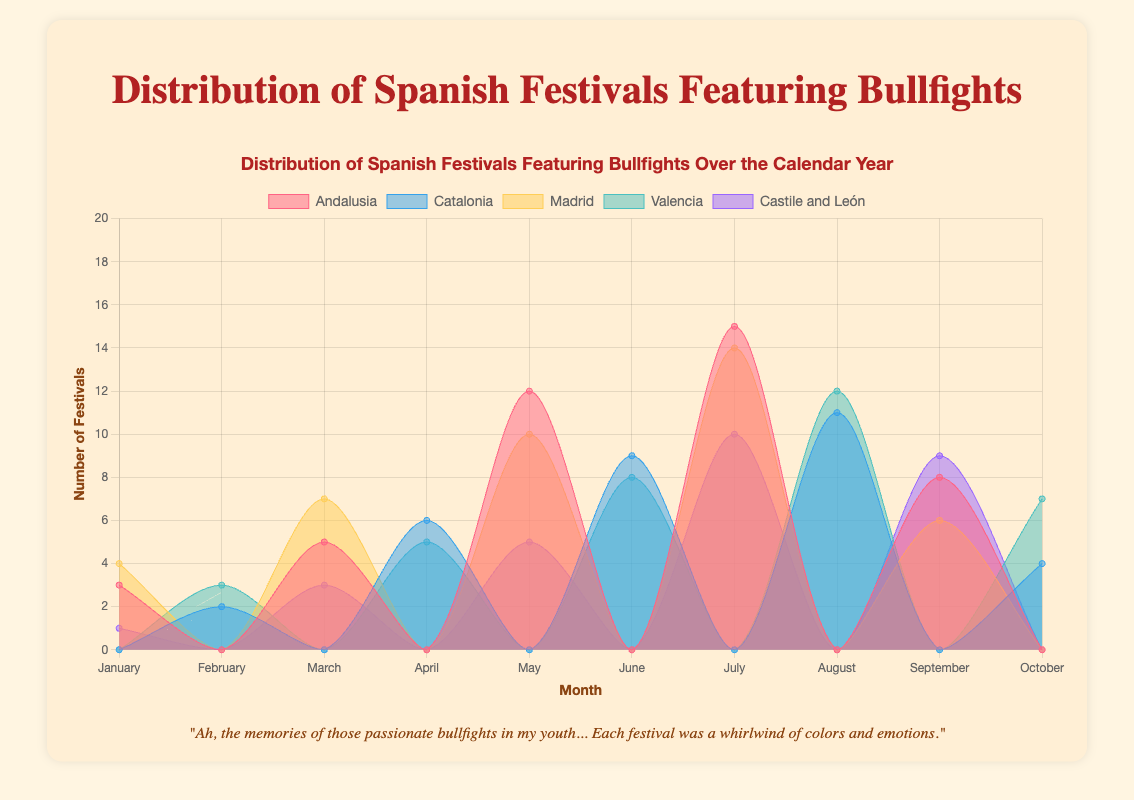Which region has the highest number of festivals in July? Look at the data points for July. Andalusia has 15, Catalonia has 0, Madrid has 14, Valencia has 0, and Castile and León has 10. So, Andalusia has the highest number.
Answer: Andalusia How many total festivals are in June across all regions? Sum the number of festivals in June for each region: Andalusia (0), Catalonia (9), Madrid (0), Valencia (8), and Castile and León (0). The total is 0 + 9 + 0 + 8 + 0 = 17.
Answer: 17 Which month has the least number of festivals overall? Examine the data points for each month across all regions and sum them up. January (3 + 0 + 4 + 0 + 1 = 8), February (0 + 2 + 0 + 3 + 0 = 5), March (5 + 0 + 7 + 0 + 3 = 15), April (0 + 6 + 0 + 5 + 0 = 11), May (12 + 0 + 10 + 0 + 5 = 27), June (0 + 9 + 0 + 8 + 0 = 17), July (15 + 0 + 14 + 0 + 10 = 39), August (0 + 11 + 0 + 12 + 0 = 23), September (8 + 0 + 6 + 0 + 9 = 23), October (0 + 4 + 0 + 7 + 0 = 11). February has the least total, which is 5.
Answer: February What is the difference in the number of festivals between Andalusia and Madrid for March? Look at the data points for March for Andalusia (5) and Madrid (7). The difference is 7 - 5 = 2.
Answer: 2 Which region has the most evenly distributed festivals throughout the year? Compare the data points for each region to see how evenly festivals are distributed across months. Castile and León has smaller differences between months (1, 0, 3, 0, 5, 0, 10, 0, 9, 0), indicating it's more evenly distributed than regions with higher peaks and troughs.
Answer: Castile and León In which month does Valencia have the highest number of festivals? Look at the data points for Valencia: February (3), April (5), June (8), August (12), October (7). The highest number is in August with 12.
Answer: August 